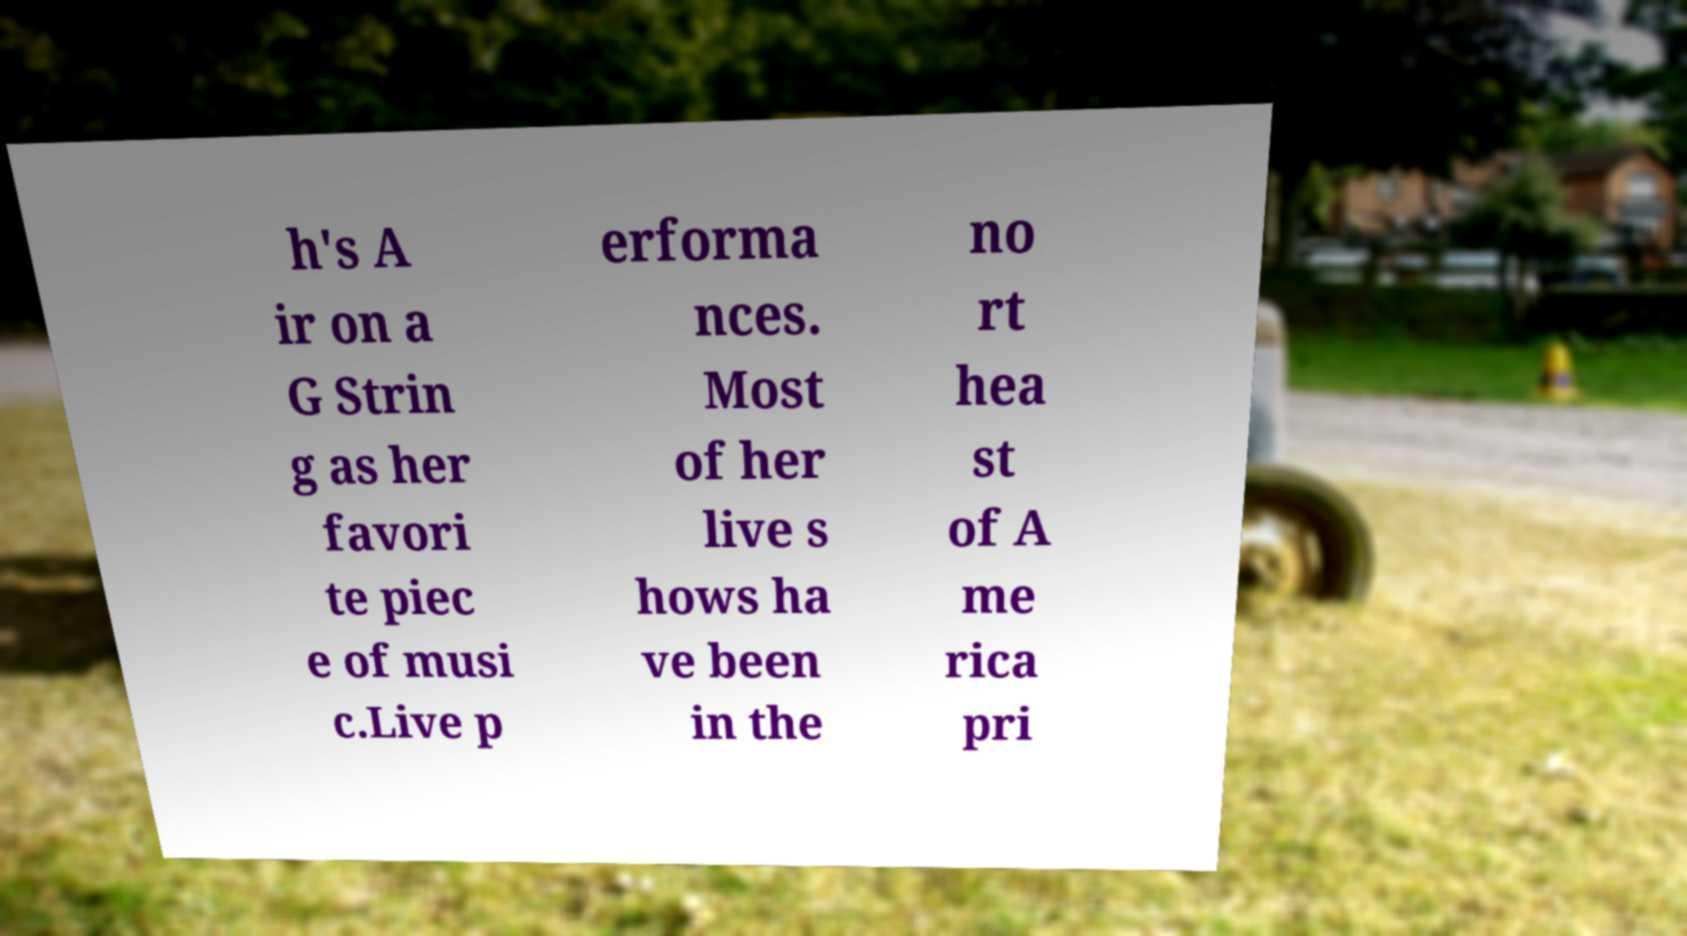What messages or text are displayed in this image? I need them in a readable, typed format. h's A ir on a G Strin g as her favori te piec e of musi c.Live p erforma nces. Most of her live s hows ha ve been in the no rt hea st of A me rica pri 